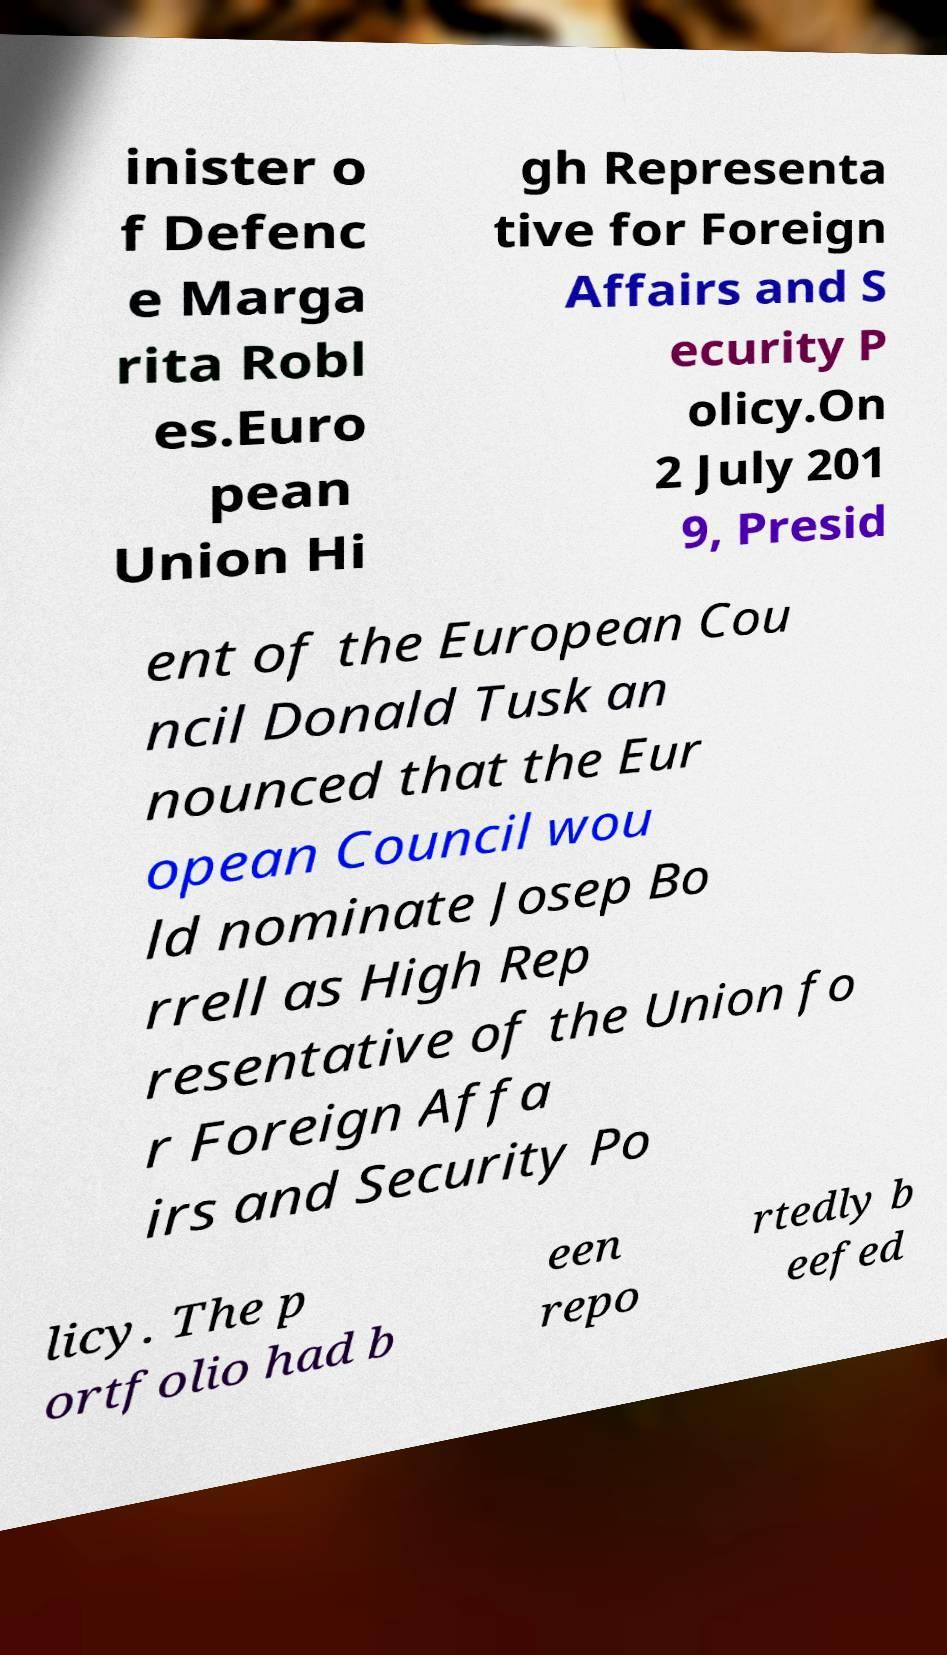Please identify and transcribe the text found in this image. inister o f Defenc e Marga rita Robl es.Euro pean Union Hi gh Representa tive for Foreign Affairs and S ecurity P olicy.On 2 July 201 9, Presid ent of the European Cou ncil Donald Tusk an nounced that the Eur opean Council wou ld nominate Josep Bo rrell as High Rep resentative of the Union fo r Foreign Affa irs and Security Po licy. The p ortfolio had b een repo rtedly b eefed 